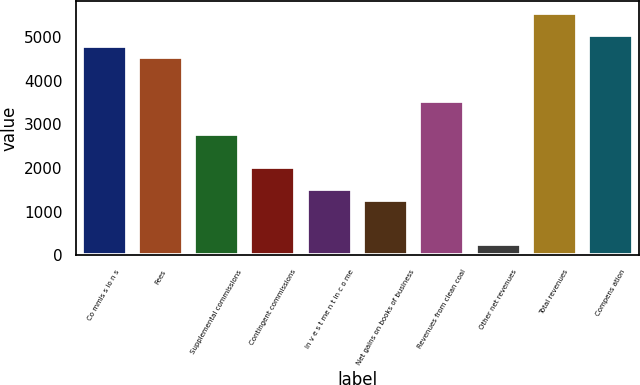Convert chart to OTSL. <chart><loc_0><loc_0><loc_500><loc_500><bar_chart><fcel>Co mmis s io n s<fcel>Fees<fcel>Supplemental commissions<fcel>Contingent commissions<fcel>In v e s t me n t in c o me<fcel>Net gains on books of business<fcel>Revenues from clean coal<fcel>Other net revenues<fcel>Total revenues<fcel>Compens ation<nl><fcel>4787.27<fcel>4535.38<fcel>2772.15<fcel>2016.48<fcel>1512.7<fcel>1260.81<fcel>3527.82<fcel>253.25<fcel>5542.94<fcel>5039.16<nl></chart> 